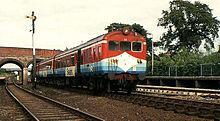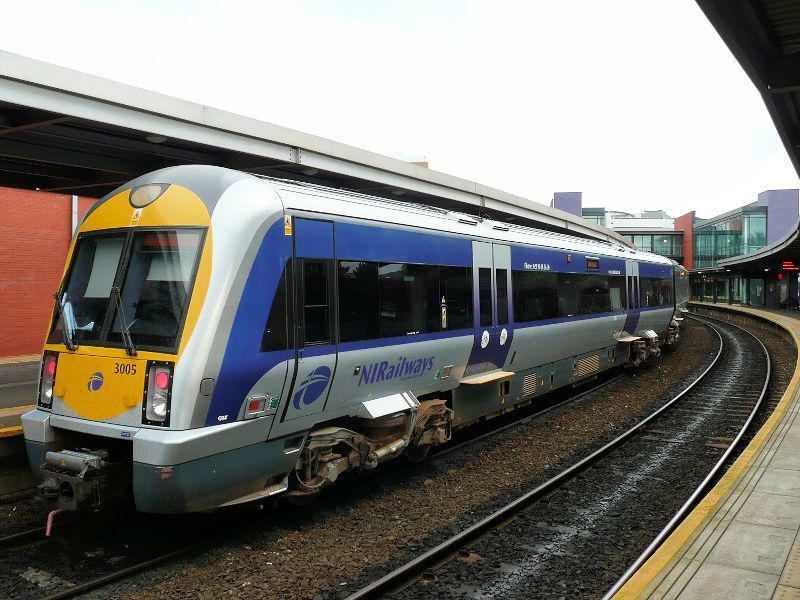The first image is the image on the left, the second image is the image on the right. For the images displayed, is the sentence "In total, the images contain two trains featuring blue and yellow coloring." factually correct? Answer yes or no. No. The first image is the image on the left, the second image is the image on the right. Assess this claim about the two images: "There are two trains in total traveling in the same direction.". Correct or not? Answer yes or no. No. 